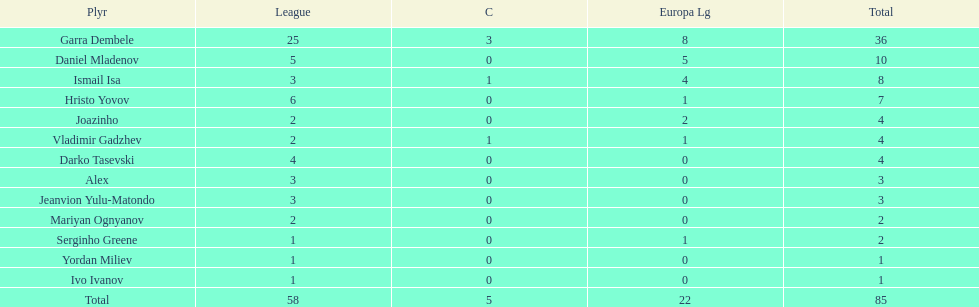Which is the only player from germany? Jeanvion Yulu-Matondo. 